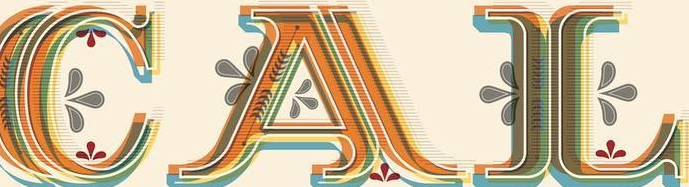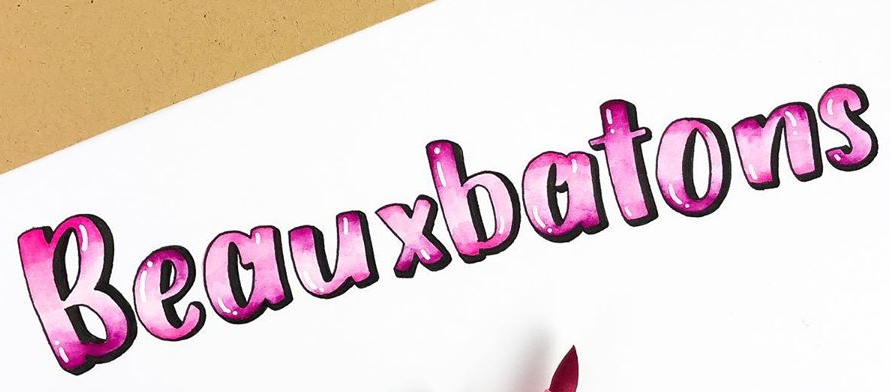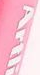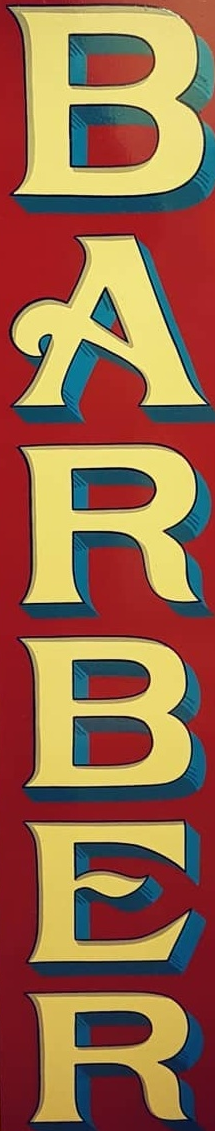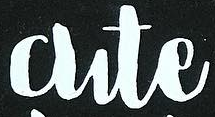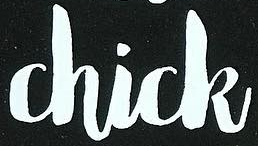What words can you see in these images in sequence, separated by a semicolon? CAL; Beauxbatons; Artli; BARBER; Cute; Chick 